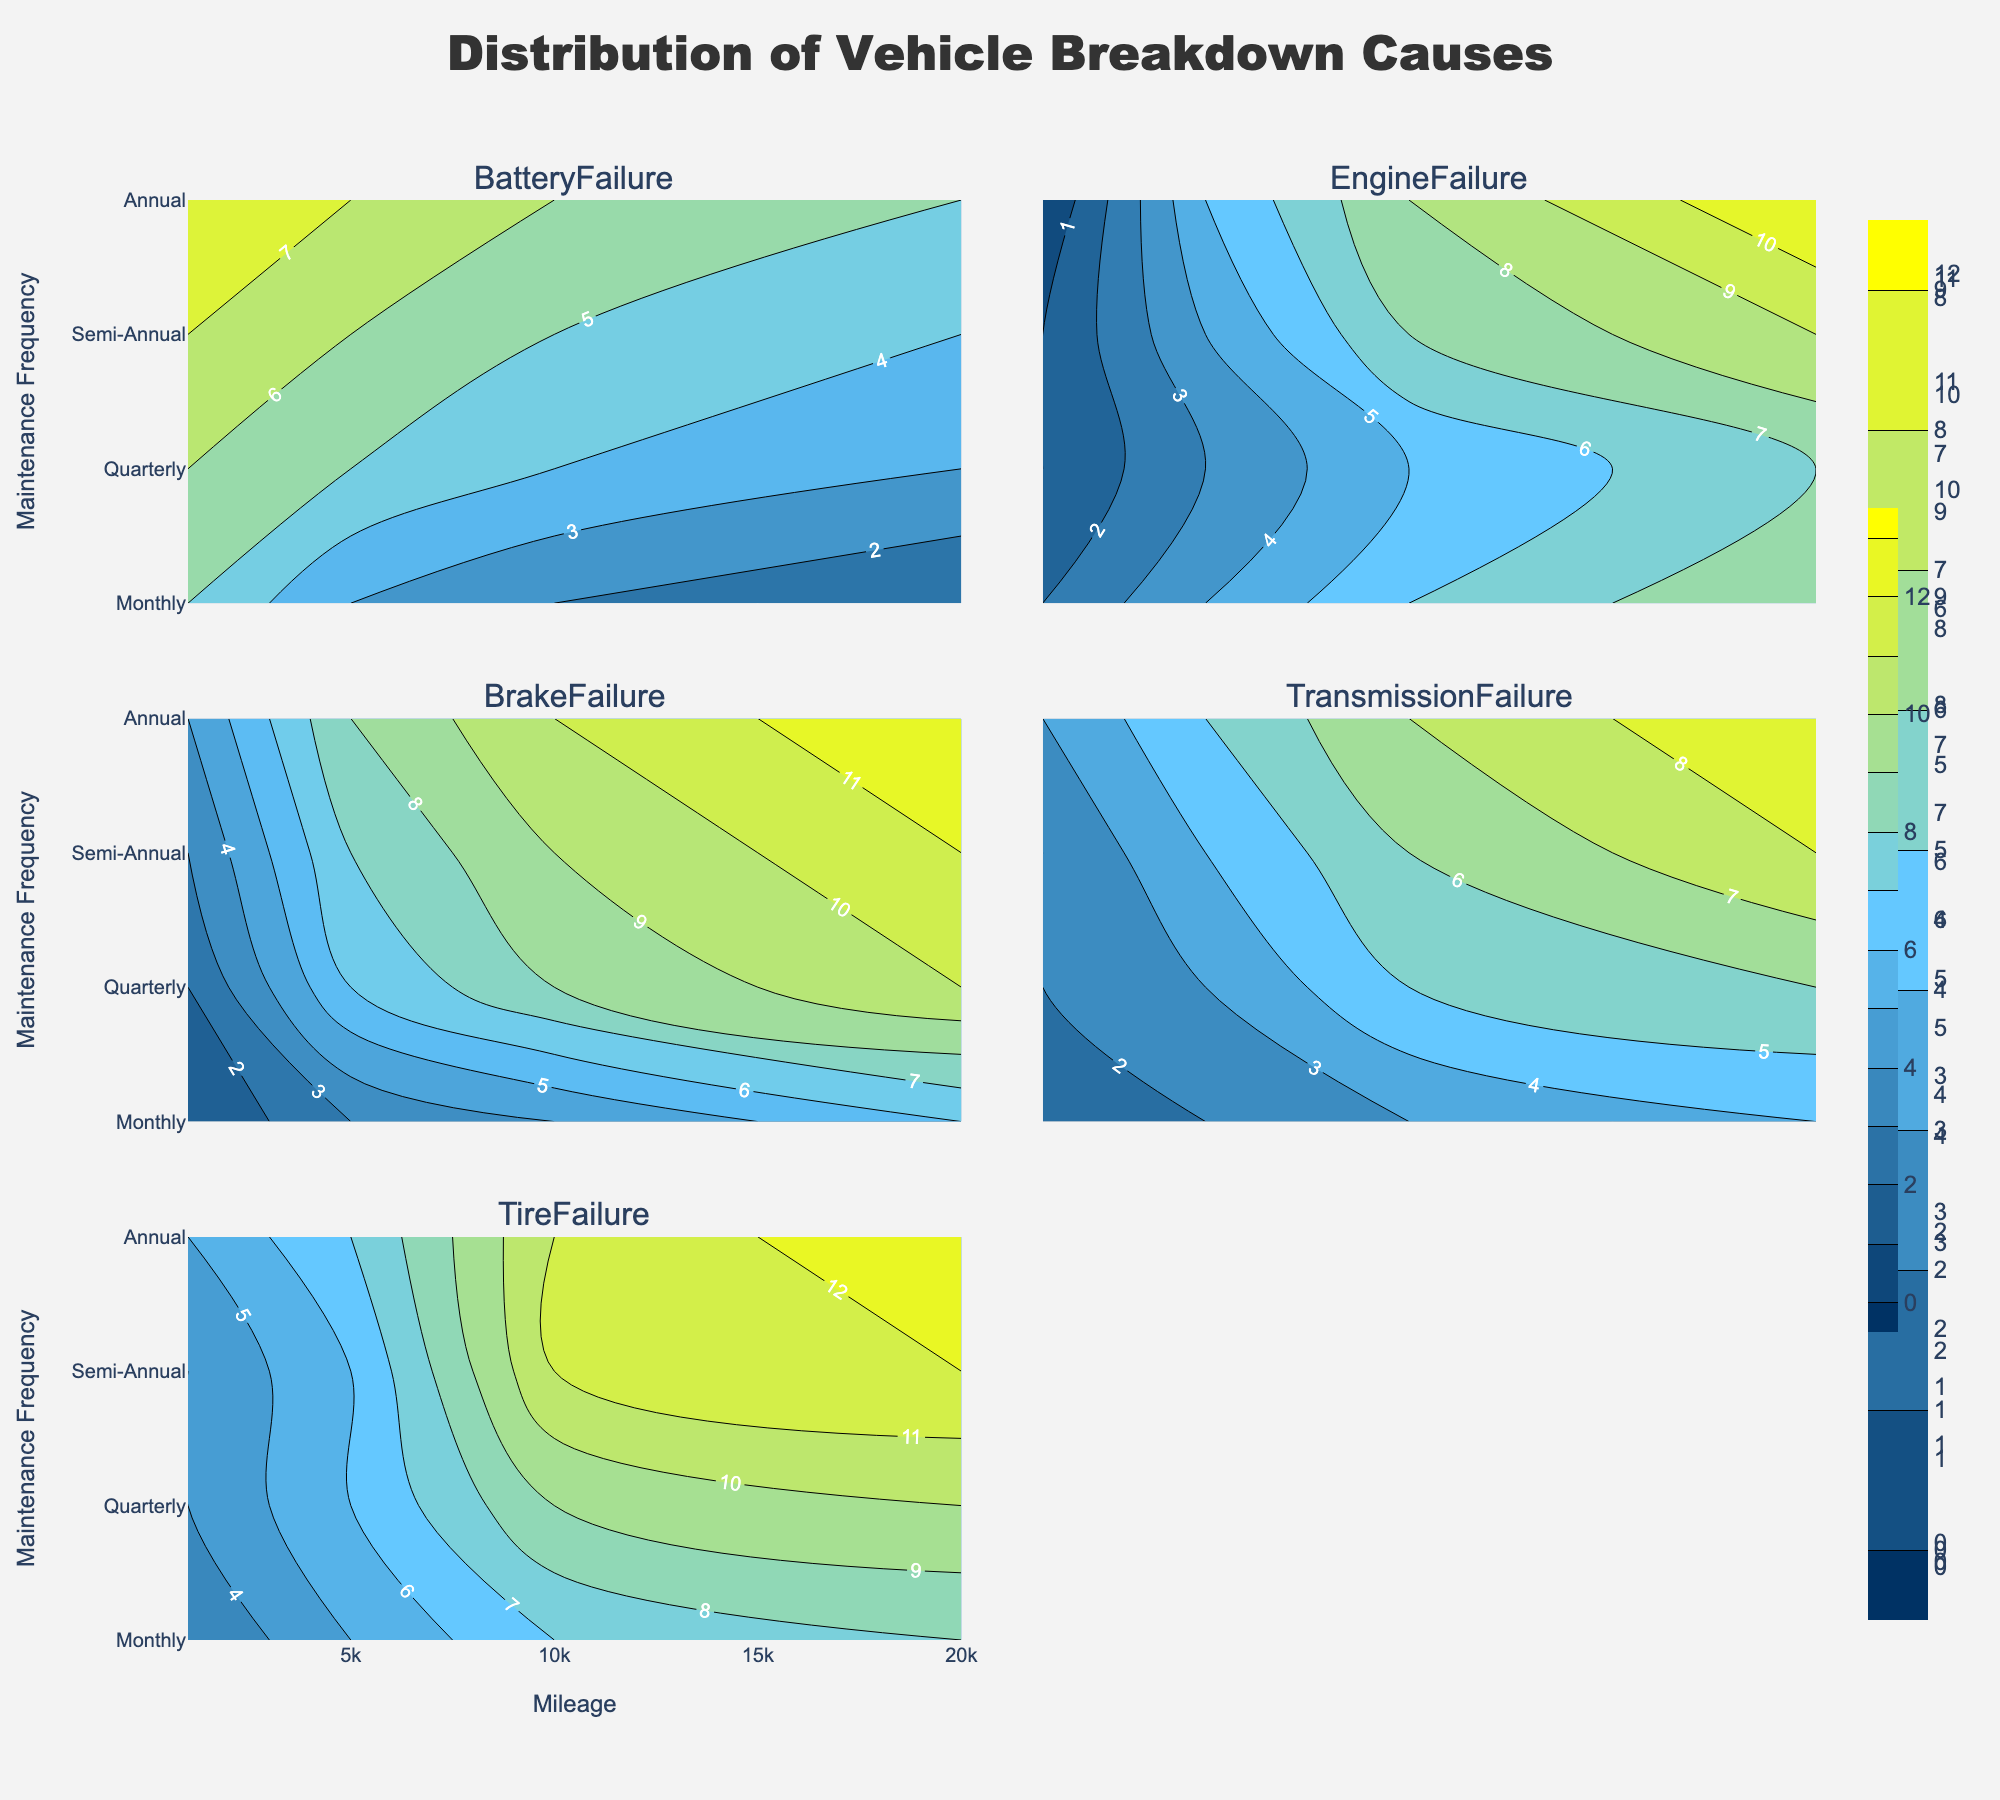Which failure type has the highest frequency for annual maintenance and 20,000 miles? By examining the contour plot for each failure type, we can identify the one with the highest contour value at the coordinates corresponding to annual maintenance and 20,000 miles.
Answer: Transmission Failure What is the frequency of tire failures for vehicles maintained semi-annually at 10,000 miles? Look at the contour plot for Tire Failure, find the value at the intersection of the Semi-Annual row and 10,000 miles column.
Answer: 11 Which maintenance frequency shows the lowest battery failure at 1,000 miles? Refer to the Battery Failure subplot and compare the values on the 1,000 miles axis across different maintenance frequencies.
Answer: Monthly How do the frequencies of engine failures compare between quarterly maintenance at 5,000 miles and annual maintenance at 10,000 miles? Look at the contour lines for Engine Failure and compare the values at quarterly maintenance with 5,000 miles and annual maintenance with 10,000 miles.
Answer: They are equal What is the trend in brake failure frequency as mileage increases for monthly maintenance? Examine the contour plot for Brake Failure and observe the values on the Monthly maintenance row as mileage increases.
Answer: Increases Which failure type exhibits the most significant increase in frequency from monthly to annual maintenance at 20,000 miles? Compare the contour values for each failure type at 20,000 miles from the Monthly to Annual row. Identify the failure type with the greatest increase.
Answer: Engine Failure For quarterly maintenance at 10,000 miles, what is the approximate frequency of transmission failures? Look at the contour plot for Transmission Failure and find the value at the intersection of Quarterly maintenance and 10,000 miles.
Answer: 5 What is the average frequency of engine failures for all maintenance frequencies at 20,000 miles? Calculate the mean by summing the engine failure values for each maintenance frequency at 20,000 miles and dividing by the number of maintenance frequencies.
Answer: 8.75 Which failure type shows the smallest frequency range across all maintenance frequencies at 1,000 miles? Calculate the difference between the maximum and minimum values for each failure type at 1,000 miles across all maintenance frequencies, and identify the one with the smallest range.
Answer: Engine Failure How does the frequency of brake failures change from semi-annual to annual maintenance at 5,000 miles? Examine the contour plot for Brake Failure and note the values for Semi-Annual and Annual maintenance at 5,000 miles.
Answer: Increases 